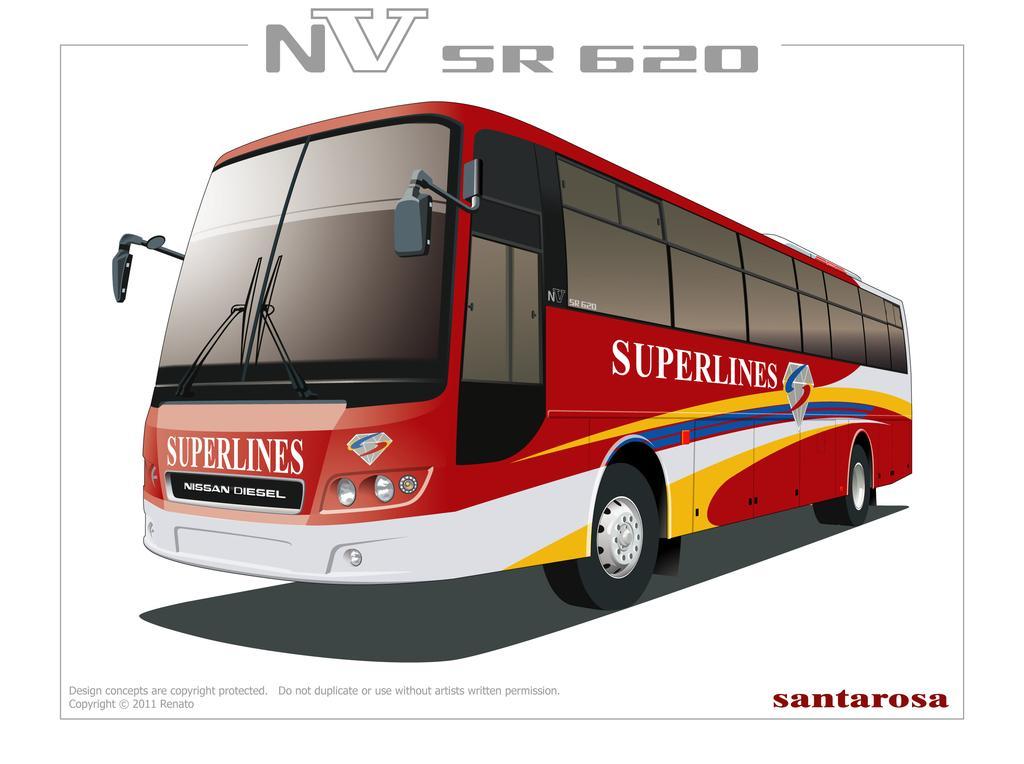Please provide a concise description of this image. In this image we can see a red color bus and here we can see some edited text. 